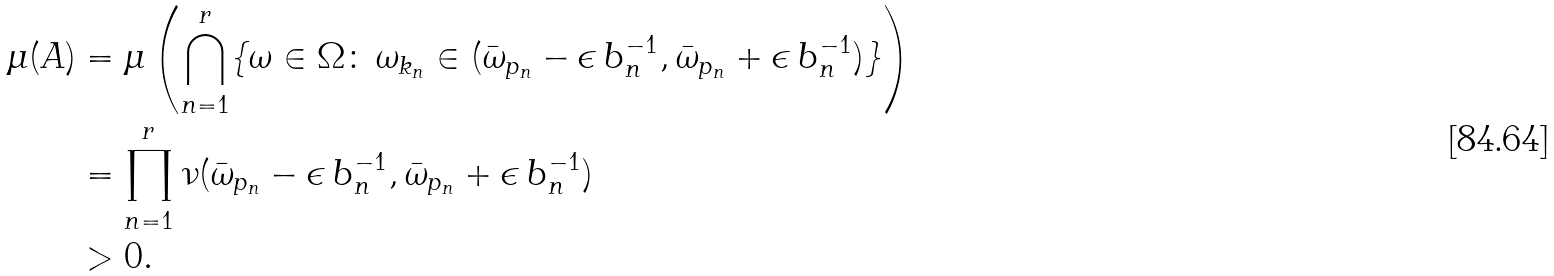<formula> <loc_0><loc_0><loc_500><loc_500>\mu ( A ) & = \mu \left ( \bigcap _ { n = 1 } ^ { r } \{ \omega \in \Omega \colon \, \omega _ { k _ { n } } \in ( \bar { \omega } _ { p _ { n } } - \epsilon \, b _ { n } ^ { - 1 } , \bar { \omega } _ { p _ { n } } + \epsilon \, b _ { n } ^ { - 1 } ) \} \right ) \\ & = \prod _ { n = 1 } ^ { r } \nu ( \bar { \omega } _ { p _ { n } } - \epsilon \, b _ { n } ^ { - 1 } , \bar { \omega } _ { p _ { n } } + \epsilon \, b _ { n } ^ { - 1 } ) \\ & > 0 .</formula> 